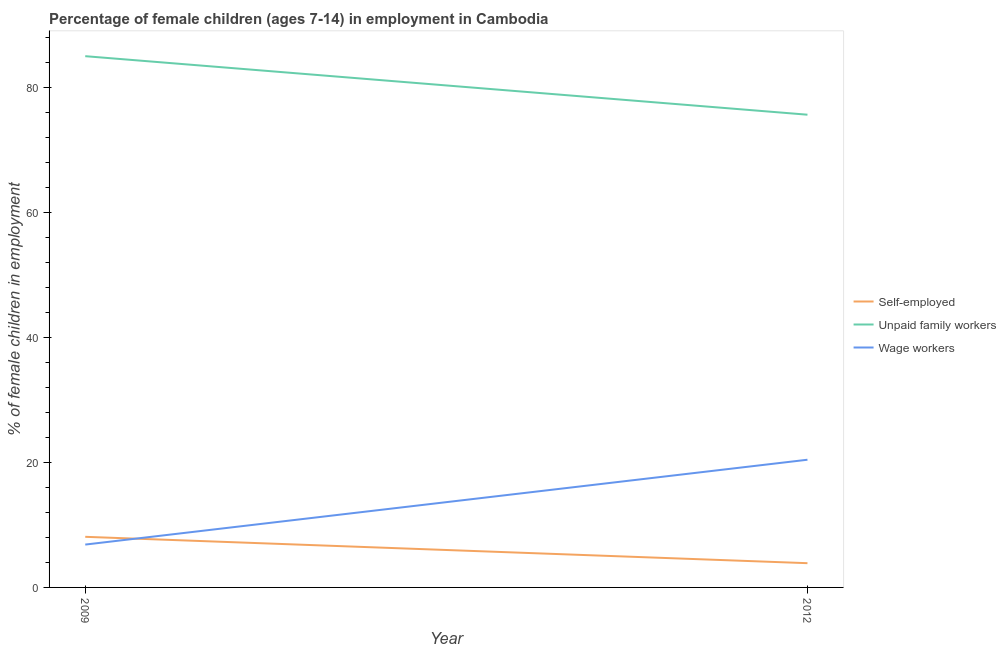Does the line corresponding to percentage of children employed as unpaid family workers intersect with the line corresponding to percentage of children employed as wage workers?
Make the answer very short. No. Across all years, what is the maximum percentage of children employed as unpaid family workers?
Your answer should be compact. 85.04. Across all years, what is the minimum percentage of children employed as unpaid family workers?
Ensure brevity in your answer.  75.67. In which year was the percentage of children employed as wage workers minimum?
Your answer should be very brief. 2009. What is the total percentage of self employed children in the graph?
Your answer should be very brief. 11.98. What is the difference between the percentage of children employed as wage workers in 2009 and that in 2012?
Give a very brief answer. -13.58. What is the difference between the percentage of children employed as unpaid family workers in 2012 and the percentage of self employed children in 2009?
Keep it short and to the point. 67.57. What is the average percentage of children employed as unpaid family workers per year?
Your answer should be compact. 80.36. In the year 2012, what is the difference between the percentage of children employed as wage workers and percentage of self employed children?
Make the answer very short. 16.56. In how many years, is the percentage of children employed as unpaid family workers greater than 12 %?
Provide a short and direct response. 2. What is the ratio of the percentage of self employed children in 2009 to that in 2012?
Your answer should be compact. 2.09. Is the percentage of children employed as wage workers in 2009 less than that in 2012?
Offer a very short reply. Yes. In how many years, is the percentage of self employed children greater than the average percentage of self employed children taken over all years?
Provide a succinct answer. 1. Is it the case that in every year, the sum of the percentage of self employed children and percentage of children employed as unpaid family workers is greater than the percentage of children employed as wage workers?
Make the answer very short. Yes. Does the percentage of self employed children monotonically increase over the years?
Your response must be concise. No. How many years are there in the graph?
Your response must be concise. 2. Are the values on the major ticks of Y-axis written in scientific E-notation?
Your answer should be very brief. No. Does the graph contain any zero values?
Offer a terse response. No. Where does the legend appear in the graph?
Keep it short and to the point. Center right. What is the title of the graph?
Your response must be concise. Percentage of female children (ages 7-14) in employment in Cambodia. What is the label or title of the Y-axis?
Provide a succinct answer. % of female children in employment. What is the % of female children in employment of Unpaid family workers in 2009?
Provide a succinct answer. 85.04. What is the % of female children in employment in Wage workers in 2009?
Make the answer very short. 6.86. What is the % of female children in employment of Self-employed in 2012?
Your answer should be compact. 3.88. What is the % of female children in employment of Unpaid family workers in 2012?
Make the answer very short. 75.67. What is the % of female children in employment in Wage workers in 2012?
Your response must be concise. 20.44. Across all years, what is the maximum % of female children in employment in Self-employed?
Your answer should be compact. 8.1. Across all years, what is the maximum % of female children in employment of Unpaid family workers?
Offer a very short reply. 85.04. Across all years, what is the maximum % of female children in employment of Wage workers?
Offer a terse response. 20.44. Across all years, what is the minimum % of female children in employment of Self-employed?
Keep it short and to the point. 3.88. Across all years, what is the minimum % of female children in employment in Unpaid family workers?
Provide a succinct answer. 75.67. Across all years, what is the minimum % of female children in employment of Wage workers?
Offer a terse response. 6.86. What is the total % of female children in employment in Self-employed in the graph?
Ensure brevity in your answer.  11.98. What is the total % of female children in employment of Unpaid family workers in the graph?
Your response must be concise. 160.71. What is the total % of female children in employment in Wage workers in the graph?
Your answer should be very brief. 27.3. What is the difference between the % of female children in employment in Self-employed in 2009 and that in 2012?
Give a very brief answer. 4.22. What is the difference between the % of female children in employment in Unpaid family workers in 2009 and that in 2012?
Your response must be concise. 9.37. What is the difference between the % of female children in employment of Wage workers in 2009 and that in 2012?
Your answer should be compact. -13.58. What is the difference between the % of female children in employment in Self-employed in 2009 and the % of female children in employment in Unpaid family workers in 2012?
Make the answer very short. -67.57. What is the difference between the % of female children in employment of Self-employed in 2009 and the % of female children in employment of Wage workers in 2012?
Provide a succinct answer. -12.34. What is the difference between the % of female children in employment in Unpaid family workers in 2009 and the % of female children in employment in Wage workers in 2012?
Provide a succinct answer. 64.6. What is the average % of female children in employment in Self-employed per year?
Provide a short and direct response. 5.99. What is the average % of female children in employment in Unpaid family workers per year?
Provide a succinct answer. 80.36. What is the average % of female children in employment in Wage workers per year?
Your answer should be compact. 13.65. In the year 2009, what is the difference between the % of female children in employment of Self-employed and % of female children in employment of Unpaid family workers?
Keep it short and to the point. -76.94. In the year 2009, what is the difference between the % of female children in employment of Self-employed and % of female children in employment of Wage workers?
Your response must be concise. 1.24. In the year 2009, what is the difference between the % of female children in employment of Unpaid family workers and % of female children in employment of Wage workers?
Provide a short and direct response. 78.18. In the year 2012, what is the difference between the % of female children in employment of Self-employed and % of female children in employment of Unpaid family workers?
Make the answer very short. -71.79. In the year 2012, what is the difference between the % of female children in employment in Self-employed and % of female children in employment in Wage workers?
Provide a succinct answer. -16.56. In the year 2012, what is the difference between the % of female children in employment of Unpaid family workers and % of female children in employment of Wage workers?
Offer a terse response. 55.23. What is the ratio of the % of female children in employment of Self-employed in 2009 to that in 2012?
Offer a very short reply. 2.09. What is the ratio of the % of female children in employment of Unpaid family workers in 2009 to that in 2012?
Offer a terse response. 1.12. What is the ratio of the % of female children in employment in Wage workers in 2009 to that in 2012?
Your response must be concise. 0.34. What is the difference between the highest and the second highest % of female children in employment of Self-employed?
Your answer should be very brief. 4.22. What is the difference between the highest and the second highest % of female children in employment in Unpaid family workers?
Provide a succinct answer. 9.37. What is the difference between the highest and the second highest % of female children in employment in Wage workers?
Offer a very short reply. 13.58. What is the difference between the highest and the lowest % of female children in employment of Self-employed?
Give a very brief answer. 4.22. What is the difference between the highest and the lowest % of female children in employment in Unpaid family workers?
Make the answer very short. 9.37. What is the difference between the highest and the lowest % of female children in employment of Wage workers?
Your response must be concise. 13.58. 